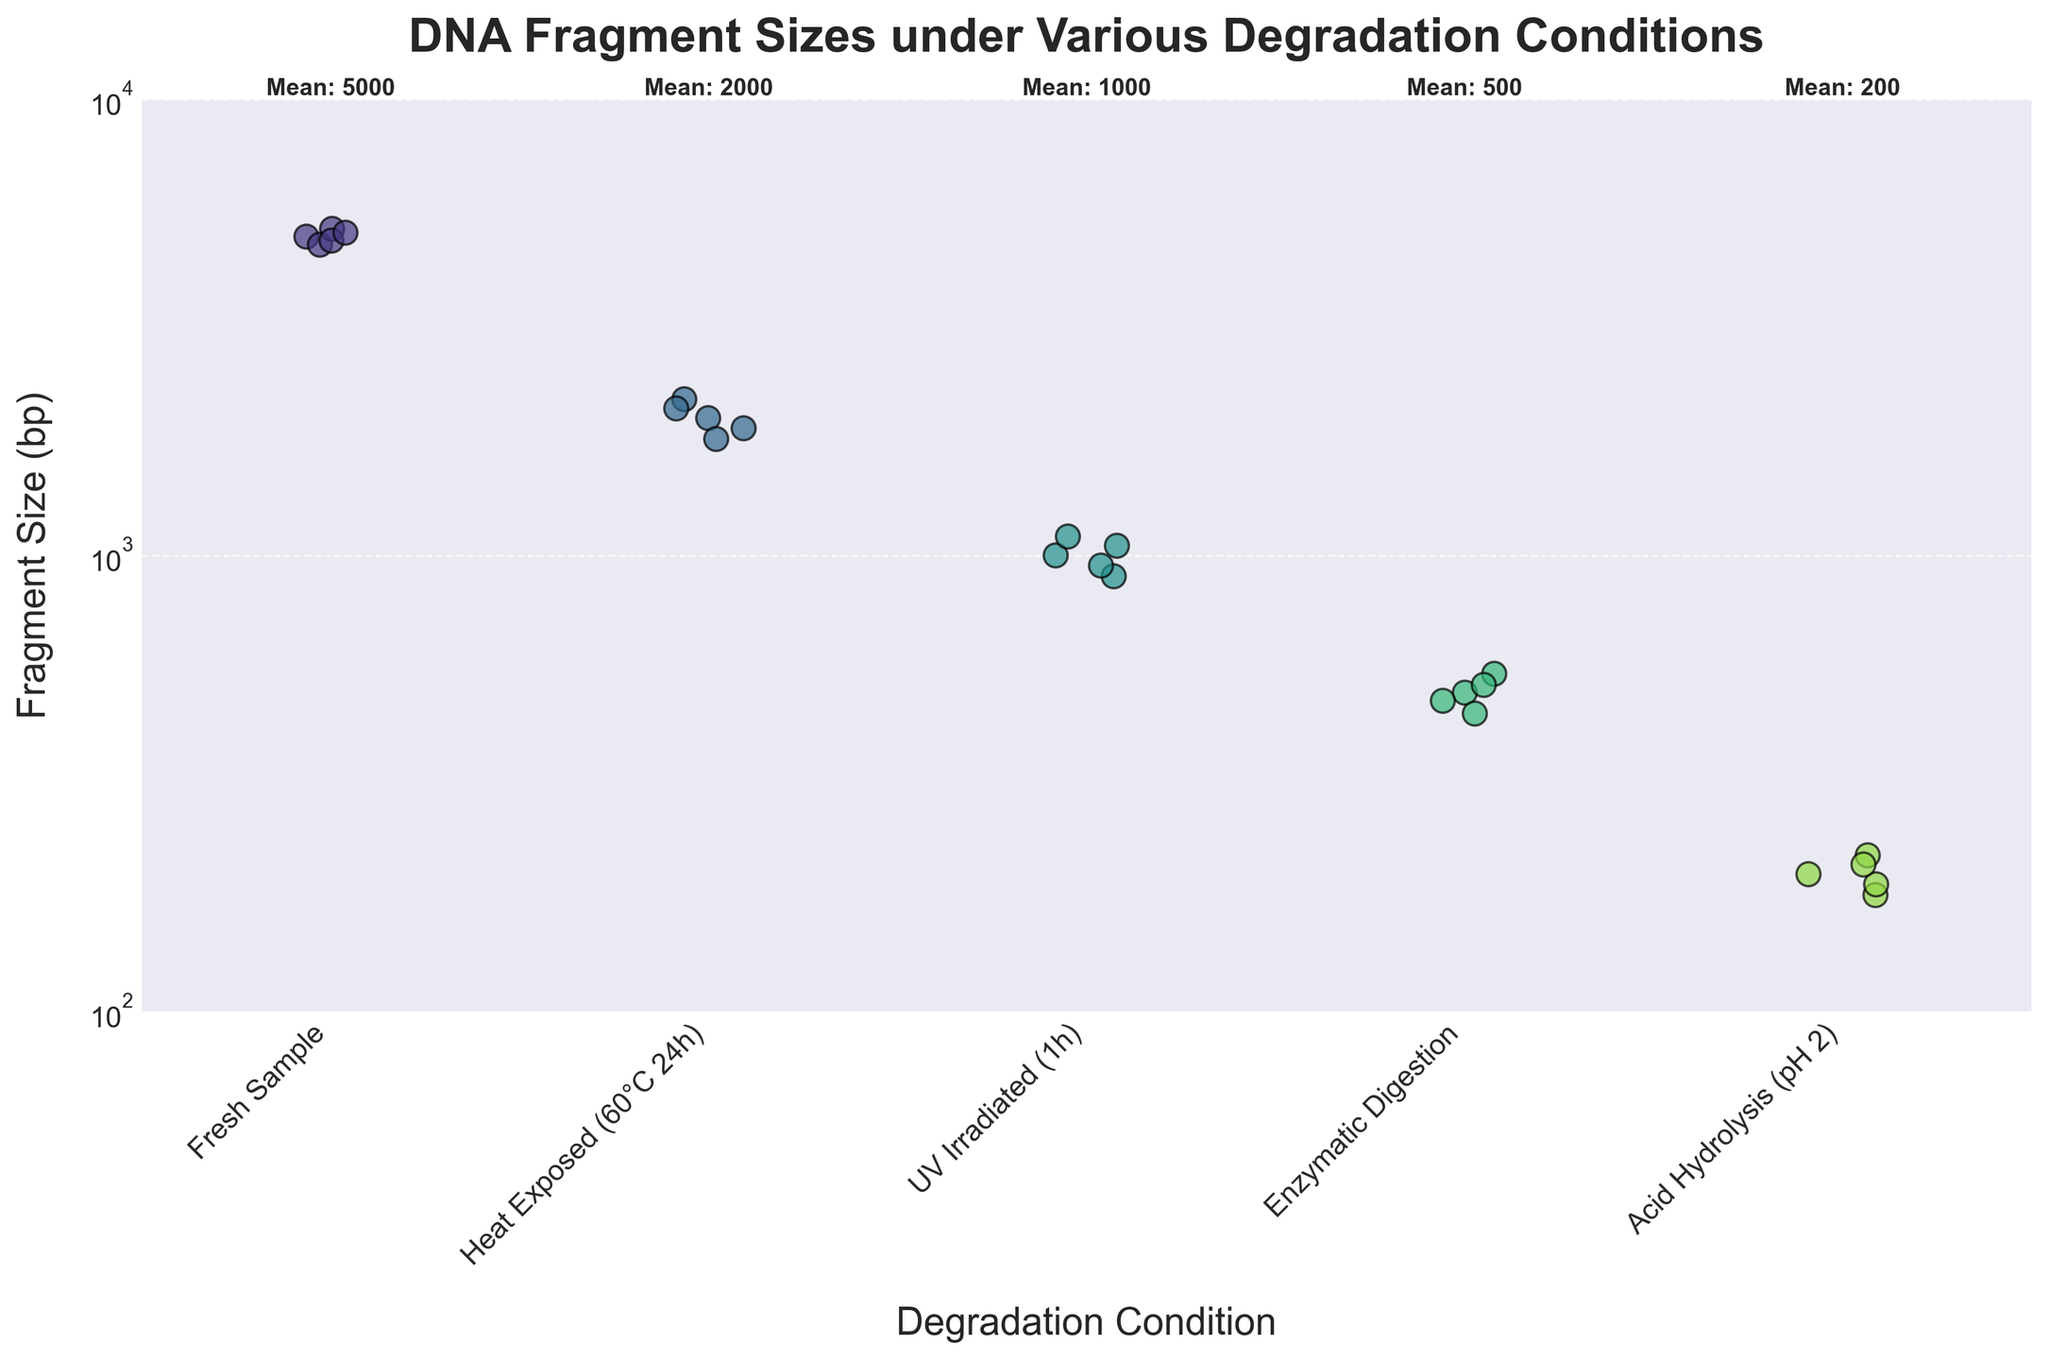What is the title of the figure? The title is at the top of the plot. Read the text displayed there.
Answer: DNA Fragment Sizes under Various Degradation Conditions How many degradation conditions are compared in the figure? Count the unique categories on the x-axis of the plot to determine the number of degradation conditions.
Answer: 5 Which degradation condition has the smallest average fragment size? Look for the "Mean" annotations above each condition on the x-axis and find the smallest numeric value.
Answer: Acid Hydrolysis (pH 2) How does the fragment size distribution for Heat Exposed (60°C 24h) compare to Fresh Sample? Observe the positions and ranges of data points (dots) for both conditions. Fresh Sample has larger values around 5000 bp, while Heat Exposed samples are clustered around 2000 bp.
Answer: Heat Exposed samples have lower fragment sizes than Fresh samples What is the range of fragment sizes for the UV Irradiated (1h) condition? Identify the lowest and highest data points (dots) under the UV Irradiated (1h) condition.
Answer: 900 bp to 1100 bp What is the median fragment size for the Acid Hydrolysis (pH 2) condition? Order the fragment sizes of Acid Hydrolysis (pH 2) (200, 180, 220, 190, 210 bp) and find the middle value.
Answer: 200 bp Which condition shows the largest variation in fragment sizes? Examine the spread of data points for each condition. The condition with the widest range represents the largest variation.
Answer: Fresh Sample How do the fragment sizes from Enzymatic Digestion compare to those of Acid Hydrolysis (pH 2)? Compare the positions and ranges of data points (dots) for both conditions. Enzymatic Digestion ranges from 450 bp to 550 bp while Acid Hydrolysis has smaller values from 180 bp to 220 bp.
Answer: Enzymatic Digestion samples have larger fragment sizes Between Heat Exposed (60°C 24h) and UV Irradiated (1h), which condition has more consistent fragment sizes, and how do you determine this? Check the spread of data points for both conditions. The condition with a smaller range of data points is more consistent.
Answer: UV Irradiated (1h), more consistent For which condition is the difference between the smallest and largest fragment size the greatest? Identify the smallest and largest data points for each condition. Calculate the difference for each and compare them. Fresh Sample ranges from 4800 to 5200, which is a difference of 400 bp, the largest observed in the data.
Answer: Fresh Sample 